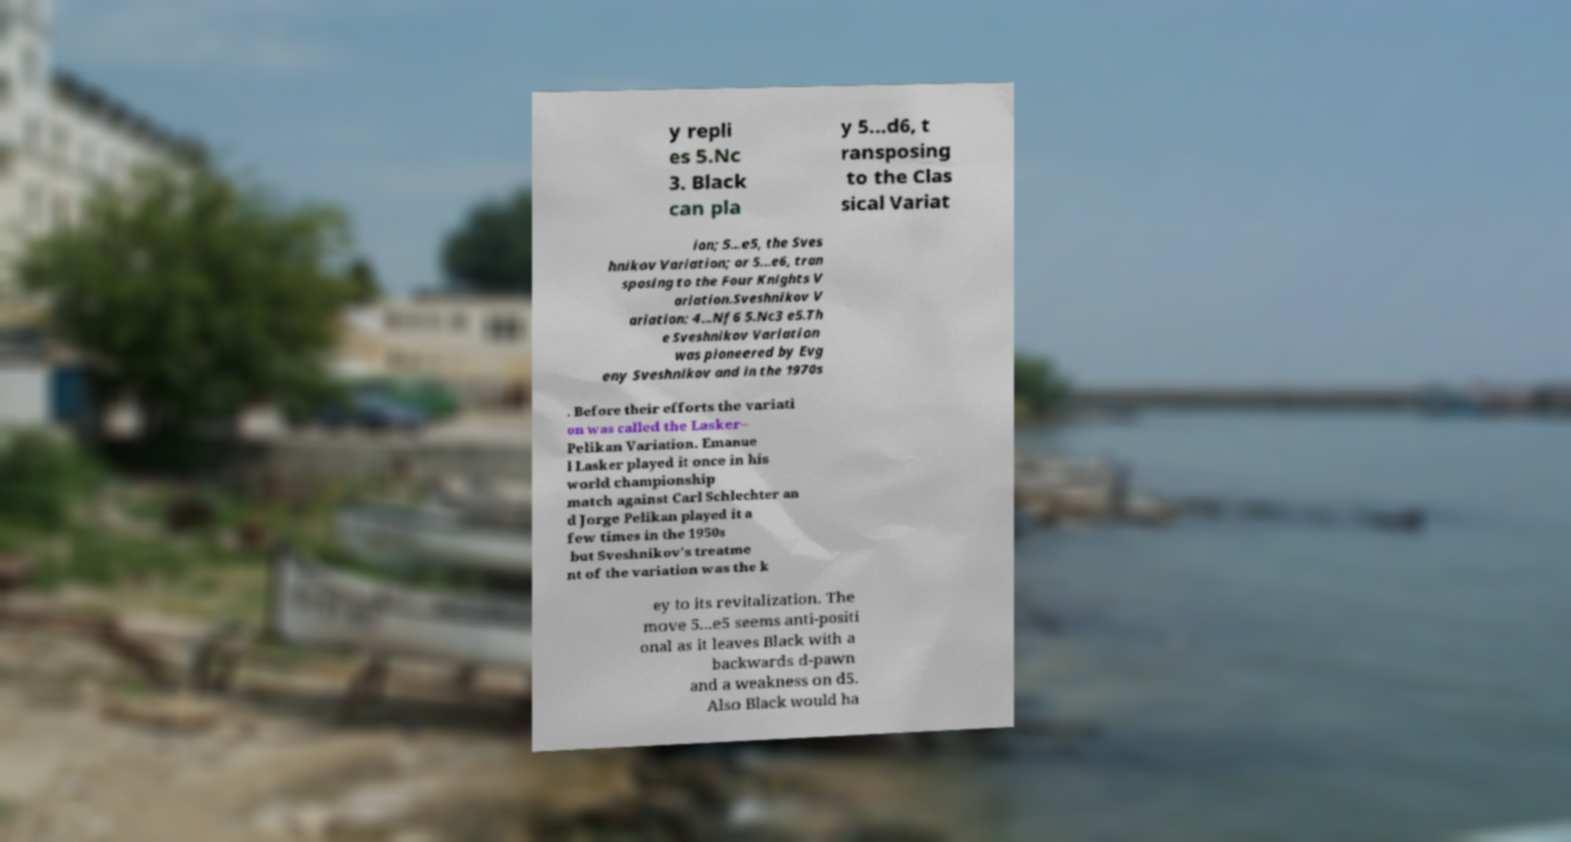Can you read and provide the text displayed in the image?This photo seems to have some interesting text. Can you extract and type it out for me? y repli es 5.Nc 3. Black can pla y 5...d6, t ransposing to the Clas sical Variat ion; 5...e5, the Sves hnikov Variation; or 5...e6, tran sposing to the Four Knights V ariation.Sveshnikov V ariation: 4...Nf6 5.Nc3 e5.Th e Sveshnikov Variation was pioneered by Evg eny Sveshnikov and in the 1970s . Before their efforts the variati on was called the Lasker– Pelikan Variation. Emanue l Lasker played it once in his world championship match against Carl Schlechter an d Jorge Pelikan played it a few times in the 1950s but Sveshnikov's treatme nt of the variation was the k ey to its revitalization. The move 5...e5 seems anti-positi onal as it leaves Black with a backwards d-pawn and a weakness on d5. Also Black would ha 